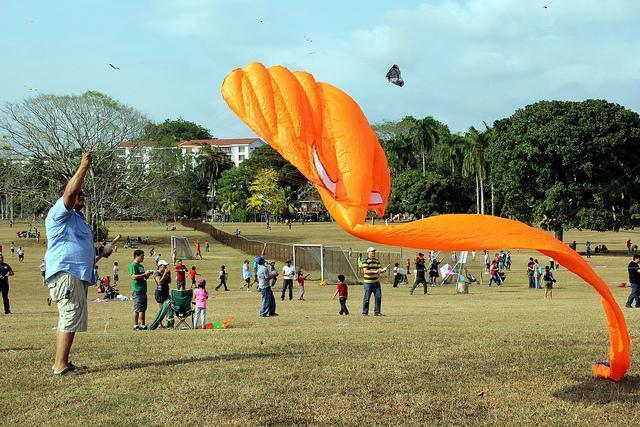How many people can be seen?
Give a very brief answer. 2. How many kinds of cake are on the table?
Give a very brief answer. 0. 